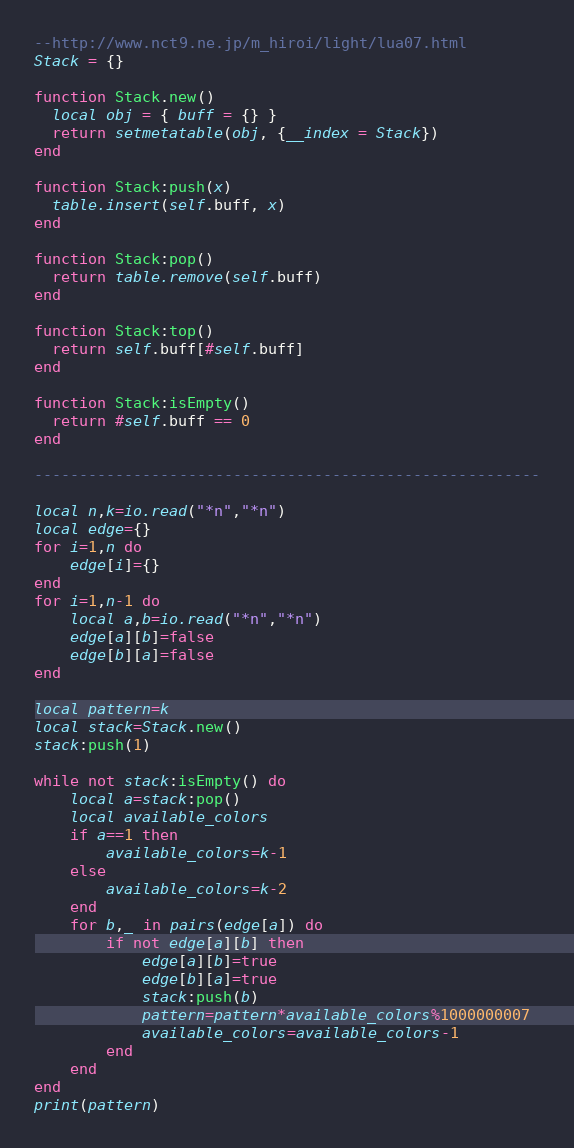<code> <loc_0><loc_0><loc_500><loc_500><_Lua_>--http://www.nct9.ne.jp/m_hiroi/light/lua07.html
Stack = {}

function Stack.new()
  local obj = { buff = {} }
  return setmetatable(obj, {__index = Stack})
end

function Stack:push(x)
  table.insert(self.buff, x)
end

function Stack:pop()
  return table.remove(self.buff)
end

function Stack:top()
  return self.buff[#self.buff]
end

function Stack:isEmpty()
  return #self.buff == 0
end

--------------------------------------------------------

local n,k=io.read("*n","*n")
local edge={}
for i=1,n do
    edge[i]={}
end
for i=1,n-1 do
    local a,b=io.read("*n","*n")
    edge[a][b]=false
    edge[b][a]=false
end

local pattern=k
local stack=Stack.new()
stack:push(1)

while not stack:isEmpty() do
    local a=stack:pop()
    local available_colors
    if a==1 then
        available_colors=k-1
    else
        available_colors=k-2
    end
    for b,_ in pairs(edge[a]) do
        if not edge[a][b] then
            edge[a][b]=true
            edge[b][a]=true
            stack:push(b)
            pattern=pattern*available_colors%1000000007
            available_colors=available_colors-1
        end
    end
end
print(pattern)</code> 